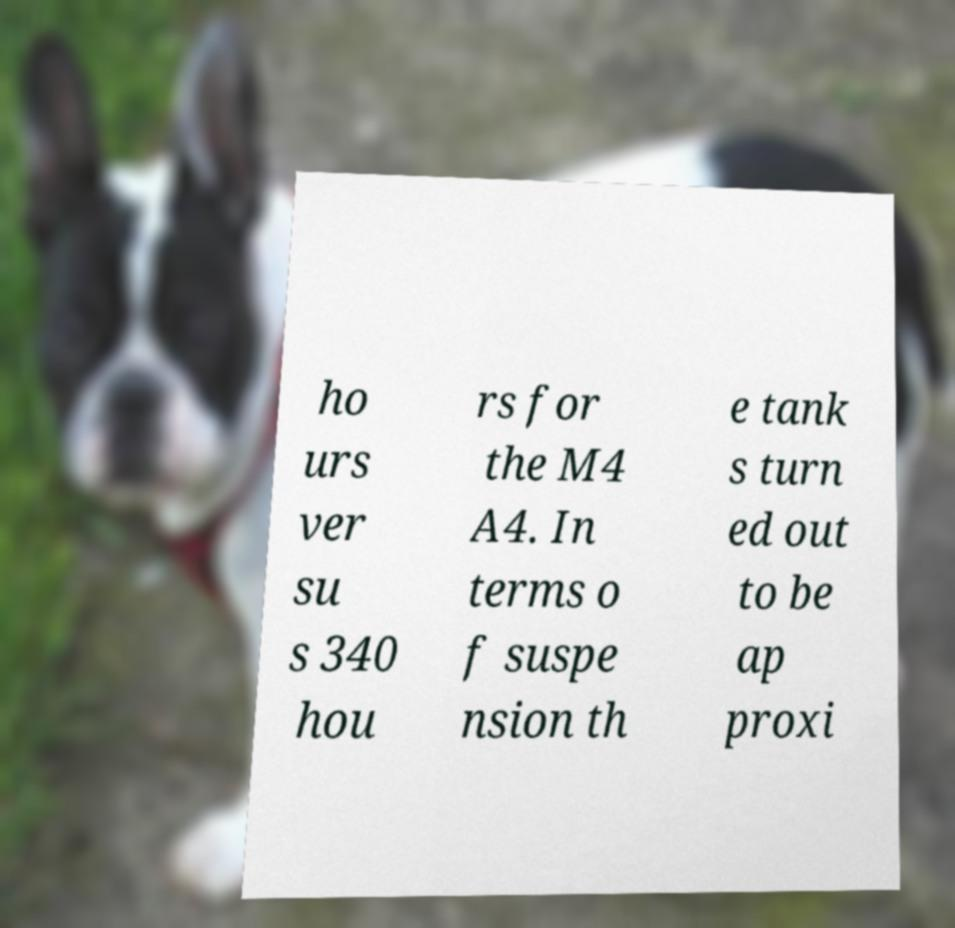Please read and relay the text visible in this image. What does it say? ho urs ver su s 340 hou rs for the M4 A4. In terms o f suspe nsion th e tank s turn ed out to be ap proxi 